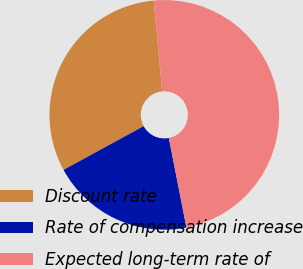Convert chart to OTSL. <chart><loc_0><loc_0><loc_500><loc_500><pie_chart><fcel>Discount rate<fcel>Rate of compensation increase<fcel>Expected long-term rate of<nl><fcel>31.49%<fcel>20.13%<fcel>48.38%<nl></chart> 